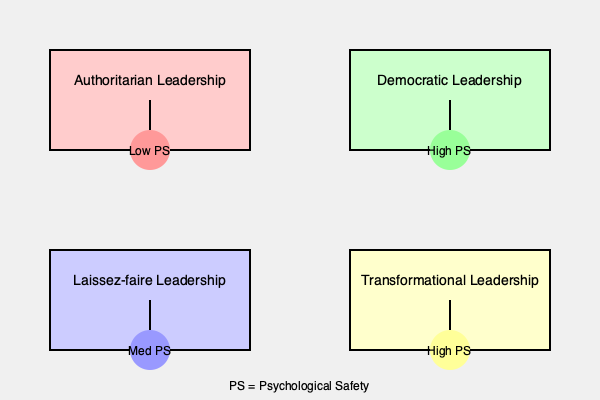Based on the organizational charts depicting different leadership styles and their impact on psychological safety, which leadership style is most likely to foster the highest level of psychological safety in an organization, and why? To answer this question, let's analyze each leadership style and its impact on psychological safety (PS):

1. Authoritarian Leadership:
   - Characterized by centralized decision-making and strict control
   - Shows low psychological safety (Low PS)
   - Employees may feel afraid to speak up or take risks

2. Democratic Leadership:
   - Involves shared decision-making and open communication
   - Shows high psychological safety (High PS)
   - Employees feel valued and are more likely to contribute ideas

3. Laissez-faire Leadership:
   - Minimal interference from leaders, high autonomy for employees
   - Shows medium psychological safety (Med PS)
   - Employees may feel empowered but might lack guidance

4. Transformational Leadership:
   - Focuses on inspiring and motivating employees to achieve goals
   - Shows high psychological safety (High PS)
   - Employees are encouraged to innovate and take calculated risks

Based on this analysis, both Democratic and Transformational leadership styles are associated with high psychological safety. However, Transformational leadership is often considered superior in fostering psychological safety because:

1. It goes beyond shared decision-making to actively inspire and motivate employees.
2. It encourages innovation and risk-taking, which are key components of psychological safety.
3. It focuses on developing employees' potential, creating a supportive environment for growth and learning.
4. It aligns individual goals with organizational objectives, creating a sense of purpose and belonging.

Therefore, while both Democratic and Transformational leadership styles promote high psychological safety, Transformational leadership is most likely to foster the highest level of psychological safety in an organization.
Answer: Transformational leadership 